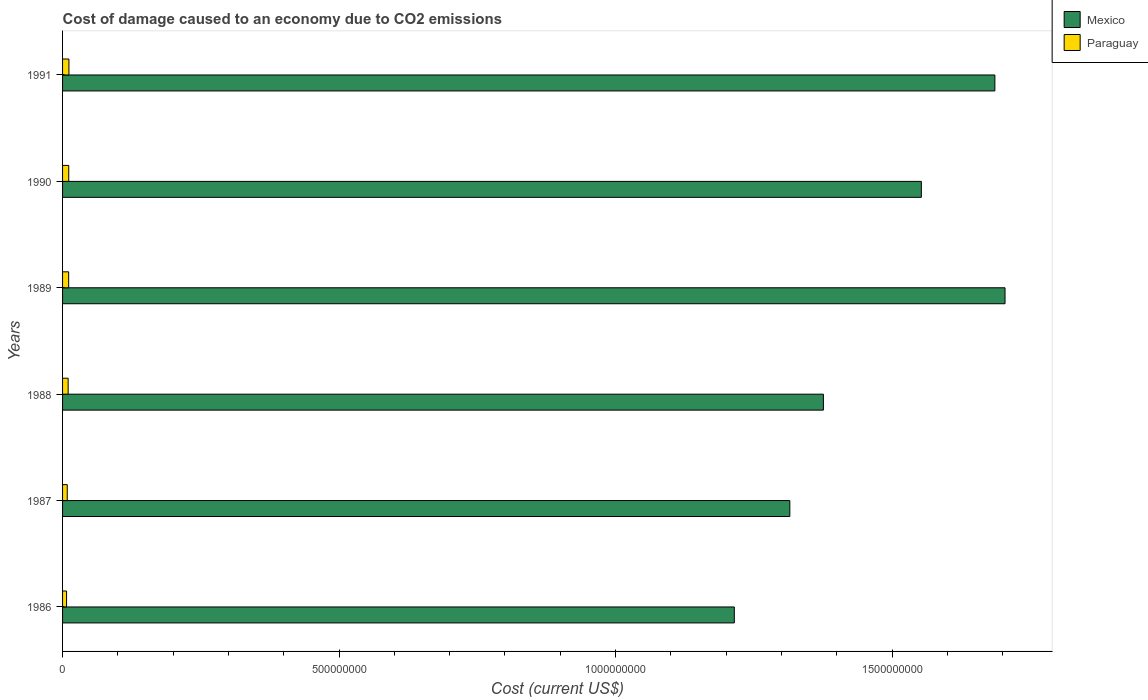Are the number of bars per tick equal to the number of legend labels?
Offer a very short reply. Yes. Are the number of bars on each tick of the Y-axis equal?
Offer a terse response. Yes. What is the cost of damage caused due to CO2 emissisons in Mexico in 1987?
Give a very brief answer. 1.32e+09. Across all years, what is the maximum cost of damage caused due to CO2 emissisons in Mexico?
Keep it short and to the point. 1.70e+09. Across all years, what is the minimum cost of damage caused due to CO2 emissisons in Paraguay?
Offer a terse response. 7.21e+06. What is the total cost of damage caused due to CO2 emissisons in Mexico in the graph?
Your answer should be very brief. 8.85e+09. What is the difference between the cost of damage caused due to CO2 emissisons in Mexico in 1989 and that in 1990?
Your answer should be very brief. 1.51e+08. What is the difference between the cost of damage caused due to CO2 emissisons in Paraguay in 1988 and the cost of damage caused due to CO2 emissisons in Mexico in 1991?
Offer a very short reply. -1.68e+09. What is the average cost of damage caused due to CO2 emissisons in Mexico per year?
Give a very brief answer. 1.47e+09. In the year 1987, what is the difference between the cost of damage caused due to CO2 emissisons in Mexico and cost of damage caused due to CO2 emissisons in Paraguay?
Your response must be concise. 1.31e+09. What is the ratio of the cost of damage caused due to CO2 emissisons in Paraguay in 1987 to that in 1989?
Offer a terse response. 0.77. Is the cost of damage caused due to CO2 emissisons in Mexico in 1987 less than that in 1989?
Provide a succinct answer. Yes. What is the difference between the highest and the second highest cost of damage caused due to CO2 emissisons in Mexico?
Offer a very short reply. 1.84e+07. What is the difference between the highest and the lowest cost of damage caused due to CO2 emissisons in Paraguay?
Your answer should be very brief. 4.32e+06. What does the 1st bar from the top in 1990 represents?
Offer a very short reply. Paraguay. What does the 2nd bar from the bottom in 1988 represents?
Ensure brevity in your answer.  Paraguay. How many bars are there?
Offer a terse response. 12. Are all the bars in the graph horizontal?
Offer a very short reply. Yes. What is the difference between two consecutive major ticks on the X-axis?
Make the answer very short. 5.00e+08. Are the values on the major ticks of X-axis written in scientific E-notation?
Offer a very short reply. No. What is the title of the graph?
Keep it short and to the point. Cost of damage caused to an economy due to CO2 emissions. Does "Cyprus" appear as one of the legend labels in the graph?
Provide a succinct answer. No. What is the label or title of the X-axis?
Give a very brief answer. Cost (current US$). What is the label or title of the Y-axis?
Keep it short and to the point. Years. What is the Cost (current US$) in Mexico in 1986?
Make the answer very short. 1.21e+09. What is the Cost (current US$) of Paraguay in 1986?
Your answer should be compact. 7.21e+06. What is the Cost (current US$) in Mexico in 1987?
Your response must be concise. 1.32e+09. What is the Cost (current US$) in Paraguay in 1987?
Keep it short and to the point. 8.46e+06. What is the Cost (current US$) of Mexico in 1988?
Offer a terse response. 1.38e+09. What is the Cost (current US$) in Paraguay in 1988?
Give a very brief answer. 1.01e+07. What is the Cost (current US$) of Mexico in 1989?
Your answer should be compact. 1.70e+09. What is the Cost (current US$) of Paraguay in 1989?
Your answer should be compact. 1.10e+07. What is the Cost (current US$) in Mexico in 1990?
Make the answer very short. 1.55e+09. What is the Cost (current US$) in Paraguay in 1990?
Offer a very short reply. 1.12e+07. What is the Cost (current US$) of Mexico in 1991?
Provide a succinct answer. 1.69e+09. What is the Cost (current US$) in Paraguay in 1991?
Ensure brevity in your answer.  1.15e+07. Across all years, what is the maximum Cost (current US$) of Mexico?
Provide a succinct answer. 1.70e+09. Across all years, what is the maximum Cost (current US$) in Paraguay?
Your answer should be very brief. 1.15e+07. Across all years, what is the minimum Cost (current US$) of Mexico?
Ensure brevity in your answer.  1.21e+09. Across all years, what is the minimum Cost (current US$) in Paraguay?
Give a very brief answer. 7.21e+06. What is the total Cost (current US$) in Mexico in the graph?
Offer a terse response. 8.85e+09. What is the total Cost (current US$) in Paraguay in the graph?
Your response must be concise. 5.95e+07. What is the difference between the Cost (current US$) in Mexico in 1986 and that in 1987?
Your answer should be very brief. -1.00e+08. What is the difference between the Cost (current US$) in Paraguay in 1986 and that in 1987?
Ensure brevity in your answer.  -1.24e+06. What is the difference between the Cost (current US$) in Mexico in 1986 and that in 1988?
Your answer should be very brief. -1.61e+08. What is the difference between the Cost (current US$) in Paraguay in 1986 and that in 1988?
Provide a short and direct response. -2.89e+06. What is the difference between the Cost (current US$) in Mexico in 1986 and that in 1989?
Your answer should be compact. -4.90e+08. What is the difference between the Cost (current US$) of Paraguay in 1986 and that in 1989?
Provide a succinct answer. -3.82e+06. What is the difference between the Cost (current US$) of Mexico in 1986 and that in 1990?
Ensure brevity in your answer.  -3.38e+08. What is the difference between the Cost (current US$) in Paraguay in 1986 and that in 1990?
Your answer should be very brief. -3.97e+06. What is the difference between the Cost (current US$) of Mexico in 1986 and that in 1991?
Offer a terse response. -4.71e+08. What is the difference between the Cost (current US$) of Paraguay in 1986 and that in 1991?
Ensure brevity in your answer.  -4.32e+06. What is the difference between the Cost (current US$) of Mexico in 1987 and that in 1988?
Your answer should be very brief. -6.07e+07. What is the difference between the Cost (current US$) in Paraguay in 1987 and that in 1988?
Keep it short and to the point. -1.65e+06. What is the difference between the Cost (current US$) of Mexico in 1987 and that in 1989?
Make the answer very short. -3.89e+08. What is the difference between the Cost (current US$) of Paraguay in 1987 and that in 1989?
Your answer should be compact. -2.58e+06. What is the difference between the Cost (current US$) in Mexico in 1987 and that in 1990?
Your answer should be very brief. -2.38e+08. What is the difference between the Cost (current US$) in Paraguay in 1987 and that in 1990?
Provide a succinct answer. -2.72e+06. What is the difference between the Cost (current US$) in Mexico in 1987 and that in 1991?
Your answer should be very brief. -3.71e+08. What is the difference between the Cost (current US$) in Paraguay in 1987 and that in 1991?
Make the answer very short. -3.08e+06. What is the difference between the Cost (current US$) in Mexico in 1988 and that in 1989?
Provide a succinct answer. -3.28e+08. What is the difference between the Cost (current US$) of Paraguay in 1988 and that in 1989?
Give a very brief answer. -9.31e+05. What is the difference between the Cost (current US$) in Mexico in 1988 and that in 1990?
Offer a very short reply. -1.77e+08. What is the difference between the Cost (current US$) of Paraguay in 1988 and that in 1990?
Your response must be concise. -1.07e+06. What is the difference between the Cost (current US$) in Mexico in 1988 and that in 1991?
Your answer should be compact. -3.10e+08. What is the difference between the Cost (current US$) in Paraguay in 1988 and that in 1991?
Your response must be concise. -1.43e+06. What is the difference between the Cost (current US$) in Mexico in 1989 and that in 1990?
Offer a terse response. 1.51e+08. What is the difference between the Cost (current US$) of Paraguay in 1989 and that in 1990?
Provide a short and direct response. -1.44e+05. What is the difference between the Cost (current US$) in Mexico in 1989 and that in 1991?
Your answer should be very brief. 1.84e+07. What is the difference between the Cost (current US$) of Paraguay in 1989 and that in 1991?
Give a very brief answer. -5.00e+05. What is the difference between the Cost (current US$) in Mexico in 1990 and that in 1991?
Your response must be concise. -1.33e+08. What is the difference between the Cost (current US$) of Paraguay in 1990 and that in 1991?
Ensure brevity in your answer.  -3.56e+05. What is the difference between the Cost (current US$) of Mexico in 1986 and the Cost (current US$) of Paraguay in 1987?
Your answer should be very brief. 1.21e+09. What is the difference between the Cost (current US$) in Mexico in 1986 and the Cost (current US$) in Paraguay in 1988?
Your answer should be very brief. 1.20e+09. What is the difference between the Cost (current US$) in Mexico in 1986 and the Cost (current US$) in Paraguay in 1989?
Make the answer very short. 1.20e+09. What is the difference between the Cost (current US$) in Mexico in 1986 and the Cost (current US$) in Paraguay in 1990?
Offer a terse response. 1.20e+09. What is the difference between the Cost (current US$) of Mexico in 1986 and the Cost (current US$) of Paraguay in 1991?
Provide a short and direct response. 1.20e+09. What is the difference between the Cost (current US$) in Mexico in 1987 and the Cost (current US$) in Paraguay in 1988?
Your answer should be very brief. 1.31e+09. What is the difference between the Cost (current US$) of Mexico in 1987 and the Cost (current US$) of Paraguay in 1989?
Provide a short and direct response. 1.30e+09. What is the difference between the Cost (current US$) in Mexico in 1987 and the Cost (current US$) in Paraguay in 1990?
Offer a very short reply. 1.30e+09. What is the difference between the Cost (current US$) in Mexico in 1987 and the Cost (current US$) in Paraguay in 1991?
Give a very brief answer. 1.30e+09. What is the difference between the Cost (current US$) of Mexico in 1988 and the Cost (current US$) of Paraguay in 1989?
Provide a short and direct response. 1.36e+09. What is the difference between the Cost (current US$) in Mexico in 1988 and the Cost (current US$) in Paraguay in 1990?
Your answer should be very brief. 1.36e+09. What is the difference between the Cost (current US$) in Mexico in 1988 and the Cost (current US$) in Paraguay in 1991?
Provide a short and direct response. 1.36e+09. What is the difference between the Cost (current US$) of Mexico in 1989 and the Cost (current US$) of Paraguay in 1990?
Your answer should be very brief. 1.69e+09. What is the difference between the Cost (current US$) of Mexico in 1989 and the Cost (current US$) of Paraguay in 1991?
Your answer should be very brief. 1.69e+09. What is the difference between the Cost (current US$) in Mexico in 1990 and the Cost (current US$) in Paraguay in 1991?
Make the answer very short. 1.54e+09. What is the average Cost (current US$) in Mexico per year?
Keep it short and to the point. 1.47e+09. What is the average Cost (current US$) of Paraguay per year?
Offer a very short reply. 9.92e+06. In the year 1986, what is the difference between the Cost (current US$) of Mexico and Cost (current US$) of Paraguay?
Your response must be concise. 1.21e+09. In the year 1987, what is the difference between the Cost (current US$) of Mexico and Cost (current US$) of Paraguay?
Your answer should be very brief. 1.31e+09. In the year 1988, what is the difference between the Cost (current US$) of Mexico and Cost (current US$) of Paraguay?
Provide a short and direct response. 1.37e+09. In the year 1989, what is the difference between the Cost (current US$) in Mexico and Cost (current US$) in Paraguay?
Make the answer very short. 1.69e+09. In the year 1990, what is the difference between the Cost (current US$) in Mexico and Cost (current US$) in Paraguay?
Your response must be concise. 1.54e+09. In the year 1991, what is the difference between the Cost (current US$) of Mexico and Cost (current US$) of Paraguay?
Offer a terse response. 1.67e+09. What is the ratio of the Cost (current US$) of Mexico in 1986 to that in 1987?
Offer a terse response. 0.92. What is the ratio of the Cost (current US$) of Paraguay in 1986 to that in 1987?
Offer a terse response. 0.85. What is the ratio of the Cost (current US$) of Mexico in 1986 to that in 1988?
Your answer should be compact. 0.88. What is the ratio of the Cost (current US$) of Paraguay in 1986 to that in 1988?
Provide a succinct answer. 0.71. What is the ratio of the Cost (current US$) in Mexico in 1986 to that in 1989?
Your answer should be compact. 0.71. What is the ratio of the Cost (current US$) of Paraguay in 1986 to that in 1989?
Provide a short and direct response. 0.65. What is the ratio of the Cost (current US$) in Mexico in 1986 to that in 1990?
Ensure brevity in your answer.  0.78. What is the ratio of the Cost (current US$) in Paraguay in 1986 to that in 1990?
Keep it short and to the point. 0.65. What is the ratio of the Cost (current US$) in Mexico in 1986 to that in 1991?
Keep it short and to the point. 0.72. What is the ratio of the Cost (current US$) of Paraguay in 1986 to that in 1991?
Your response must be concise. 0.63. What is the ratio of the Cost (current US$) in Mexico in 1987 to that in 1988?
Offer a terse response. 0.96. What is the ratio of the Cost (current US$) in Paraguay in 1987 to that in 1988?
Make the answer very short. 0.84. What is the ratio of the Cost (current US$) in Mexico in 1987 to that in 1989?
Ensure brevity in your answer.  0.77. What is the ratio of the Cost (current US$) in Paraguay in 1987 to that in 1989?
Keep it short and to the point. 0.77. What is the ratio of the Cost (current US$) in Mexico in 1987 to that in 1990?
Your response must be concise. 0.85. What is the ratio of the Cost (current US$) in Paraguay in 1987 to that in 1990?
Your answer should be compact. 0.76. What is the ratio of the Cost (current US$) in Mexico in 1987 to that in 1991?
Provide a succinct answer. 0.78. What is the ratio of the Cost (current US$) in Paraguay in 1987 to that in 1991?
Ensure brevity in your answer.  0.73. What is the ratio of the Cost (current US$) of Mexico in 1988 to that in 1989?
Provide a succinct answer. 0.81. What is the ratio of the Cost (current US$) of Paraguay in 1988 to that in 1989?
Your answer should be very brief. 0.92. What is the ratio of the Cost (current US$) in Mexico in 1988 to that in 1990?
Ensure brevity in your answer.  0.89. What is the ratio of the Cost (current US$) in Paraguay in 1988 to that in 1990?
Your answer should be very brief. 0.9. What is the ratio of the Cost (current US$) in Mexico in 1988 to that in 1991?
Keep it short and to the point. 0.82. What is the ratio of the Cost (current US$) of Paraguay in 1988 to that in 1991?
Offer a terse response. 0.88. What is the ratio of the Cost (current US$) of Mexico in 1989 to that in 1990?
Make the answer very short. 1.1. What is the ratio of the Cost (current US$) in Paraguay in 1989 to that in 1990?
Ensure brevity in your answer.  0.99. What is the ratio of the Cost (current US$) in Mexico in 1989 to that in 1991?
Your answer should be compact. 1.01. What is the ratio of the Cost (current US$) of Paraguay in 1989 to that in 1991?
Your answer should be compact. 0.96. What is the ratio of the Cost (current US$) of Mexico in 1990 to that in 1991?
Your answer should be very brief. 0.92. What is the ratio of the Cost (current US$) in Paraguay in 1990 to that in 1991?
Your answer should be compact. 0.97. What is the difference between the highest and the second highest Cost (current US$) of Mexico?
Provide a succinct answer. 1.84e+07. What is the difference between the highest and the second highest Cost (current US$) of Paraguay?
Provide a succinct answer. 3.56e+05. What is the difference between the highest and the lowest Cost (current US$) in Mexico?
Offer a very short reply. 4.90e+08. What is the difference between the highest and the lowest Cost (current US$) in Paraguay?
Offer a terse response. 4.32e+06. 